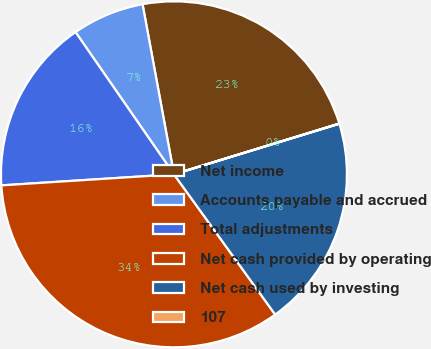<chart> <loc_0><loc_0><loc_500><loc_500><pie_chart><fcel>Net income<fcel>Accounts payable and accrued<fcel>Total adjustments<fcel>Net cash provided by operating<fcel>Net cash used by investing<fcel>107<nl><fcel>23.16%<fcel>6.73%<fcel>16.38%<fcel>33.93%<fcel>19.77%<fcel>0.02%<nl></chart> 